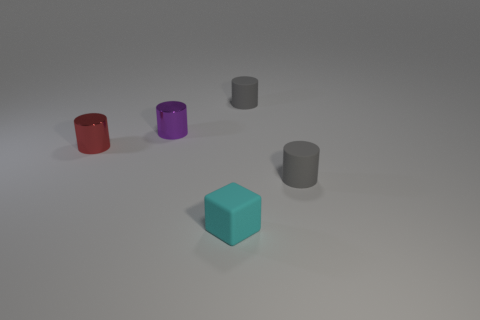The small cylinder that is behind the red metallic cylinder and to the right of the purple object is made of what material?
Provide a succinct answer. Rubber. Is the size of the rubber cylinder behind the purple shiny cylinder the same as the tiny purple cylinder?
Give a very brief answer. Yes. What is the shape of the small purple thing?
Offer a very short reply. Cylinder. What number of gray rubber objects have the same shape as the purple metallic thing?
Offer a very short reply. 2. What number of tiny objects are in front of the purple cylinder and to the left of the small cyan object?
Offer a terse response. 1. The tiny block is what color?
Provide a short and direct response. Cyan. Is there a large purple thing that has the same material as the small red cylinder?
Provide a succinct answer. No. Is there a tiny block that is behind the small gray rubber cylinder that is left of the small gray cylinder in front of the tiny red shiny cylinder?
Make the answer very short. No. There is a red metal object; are there any cyan matte blocks behind it?
Keep it short and to the point. No. Is there a small shiny cylinder of the same color as the small matte block?
Give a very brief answer. No. 